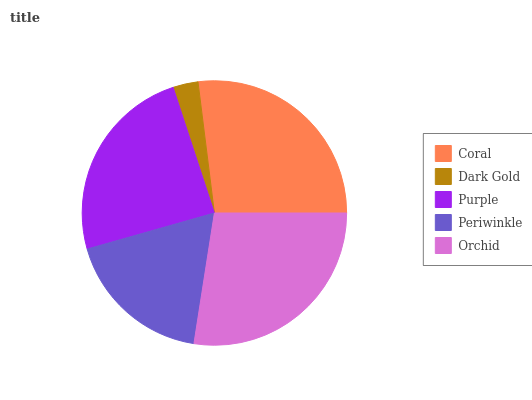Is Dark Gold the minimum?
Answer yes or no. Yes. Is Orchid the maximum?
Answer yes or no. Yes. Is Purple the minimum?
Answer yes or no. No. Is Purple the maximum?
Answer yes or no. No. Is Purple greater than Dark Gold?
Answer yes or no. Yes. Is Dark Gold less than Purple?
Answer yes or no. Yes. Is Dark Gold greater than Purple?
Answer yes or no. No. Is Purple less than Dark Gold?
Answer yes or no. No. Is Purple the high median?
Answer yes or no. Yes. Is Purple the low median?
Answer yes or no. Yes. Is Periwinkle the high median?
Answer yes or no. No. Is Dark Gold the low median?
Answer yes or no. No. 